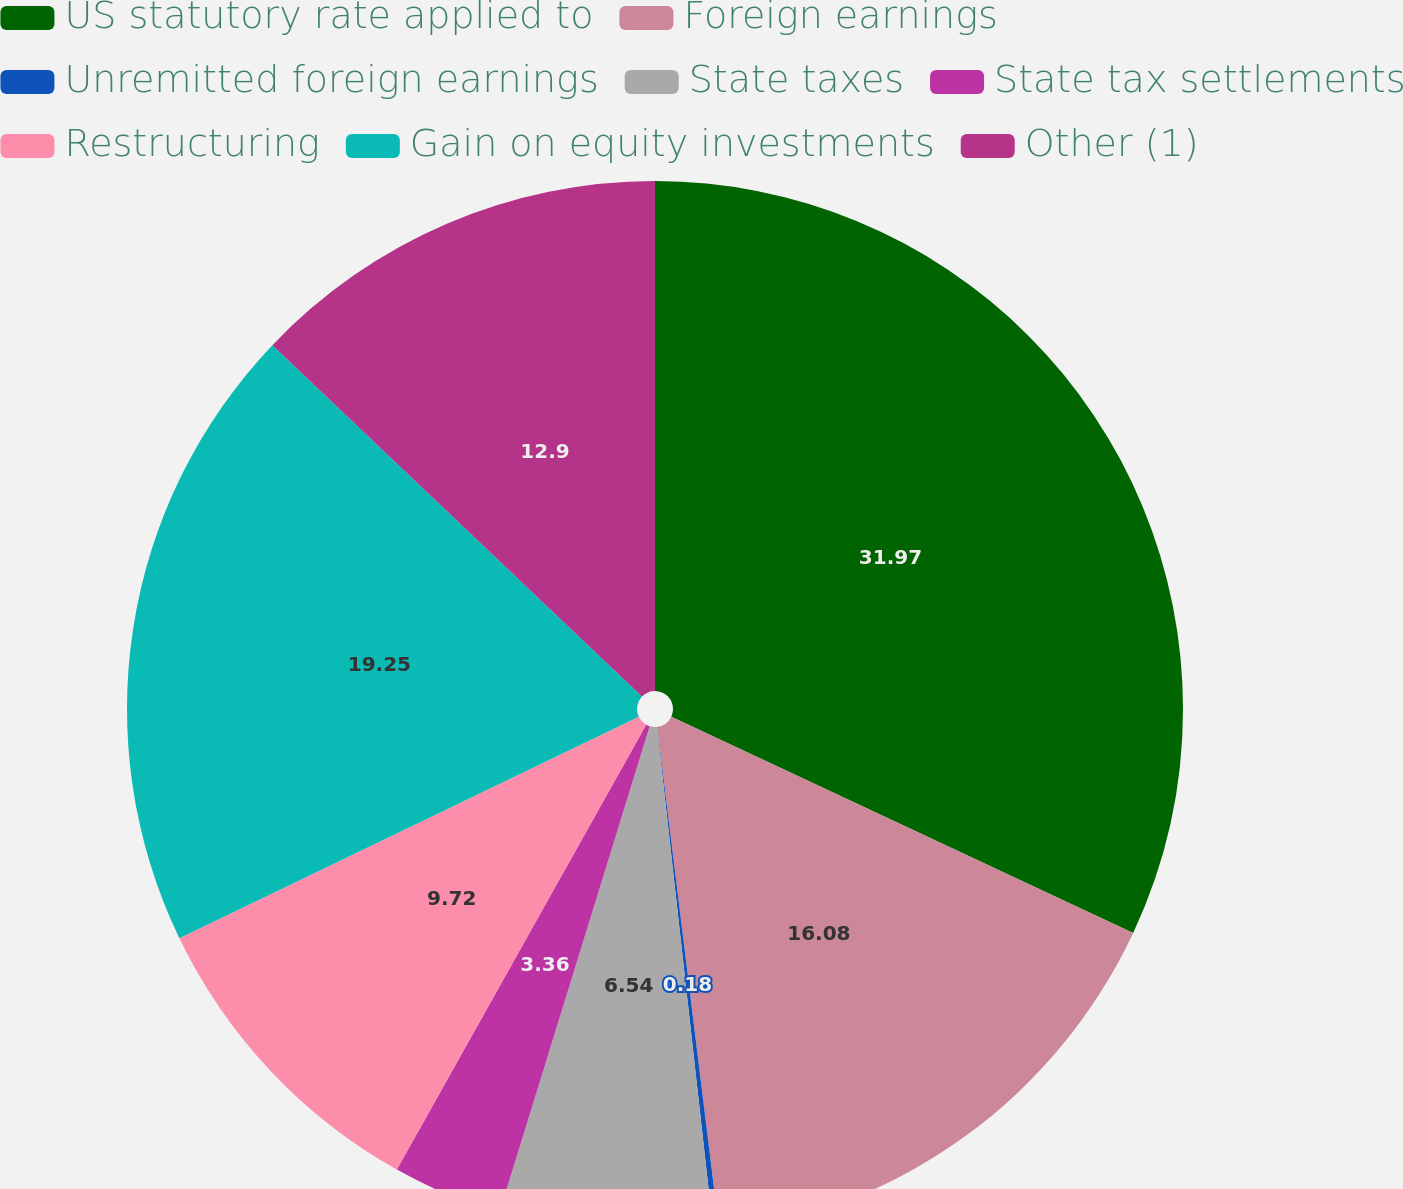Convert chart. <chart><loc_0><loc_0><loc_500><loc_500><pie_chart><fcel>US statutory rate applied to<fcel>Foreign earnings<fcel>Unremitted foreign earnings<fcel>State taxes<fcel>State tax settlements<fcel>Restructuring<fcel>Gain on equity investments<fcel>Other (1)<nl><fcel>31.97%<fcel>16.08%<fcel>0.18%<fcel>6.54%<fcel>3.36%<fcel>9.72%<fcel>19.25%<fcel>12.9%<nl></chart> 